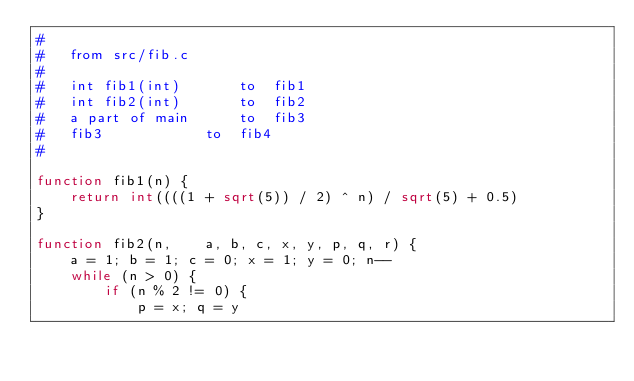Convert code to text. <code><loc_0><loc_0><loc_500><loc_500><_Awk_>#
#	from src/fib.c
#
#	int fib1(int)		to	fib1
#	int fib2(int)		to	fib2
#	a part of main		to	fib3
#	fib3			to	fib4
#

function fib1(n) {
	return int((((1 + sqrt(5)) / 2) ^ n) / sqrt(5) + 0.5)
}

function fib2(n,	a, b, c, x, y, p, q, r) {
	a = 1; b = 1; c = 0; x = 1; y = 0; n--
	while (n > 0) {
		if (n % 2 != 0) {
			p = x; q = y</code> 